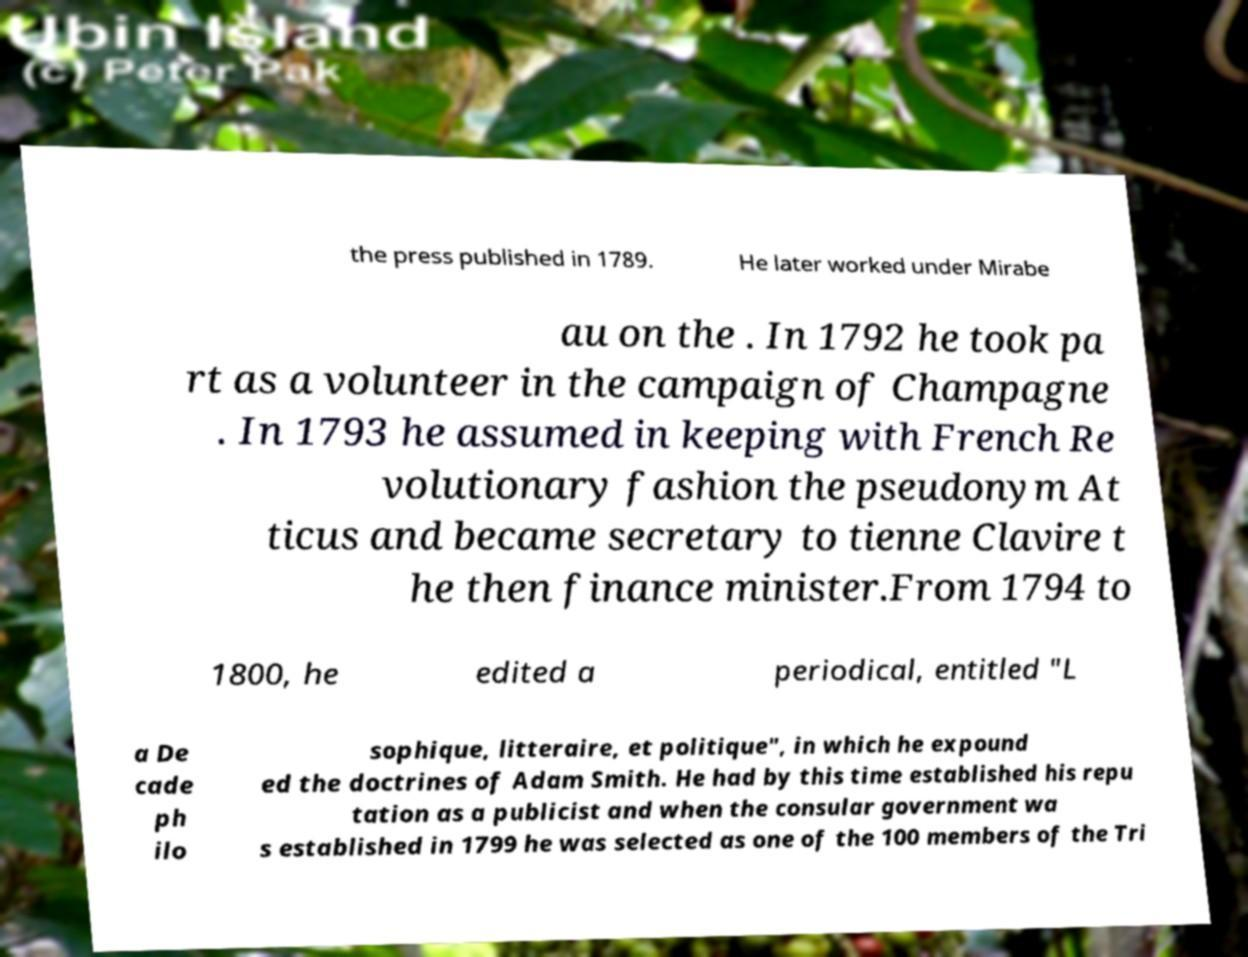There's text embedded in this image that I need extracted. Can you transcribe it verbatim? the press published in 1789. He later worked under Mirabe au on the . In 1792 he took pa rt as a volunteer in the campaign of Champagne . In 1793 he assumed in keeping with French Re volutionary fashion the pseudonym At ticus and became secretary to tienne Clavire t he then finance minister.From 1794 to 1800, he edited a periodical, entitled "L a De cade ph ilo sophique, litteraire, et politique", in which he expound ed the doctrines of Adam Smith. He had by this time established his repu tation as a publicist and when the consular government wa s established in 1799 he was selected as one of the 100 members of the Tri 